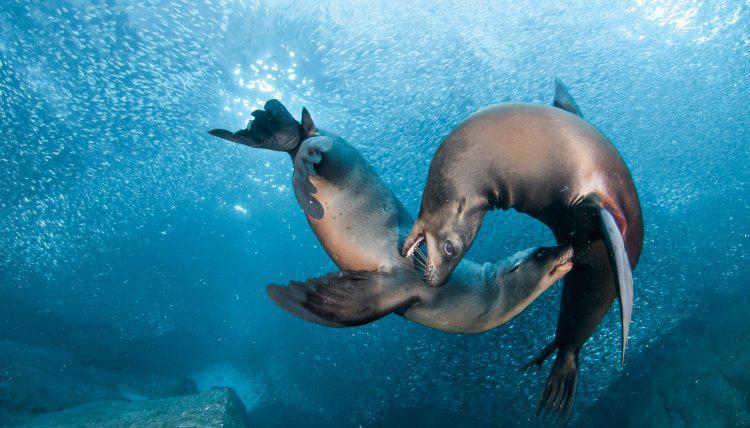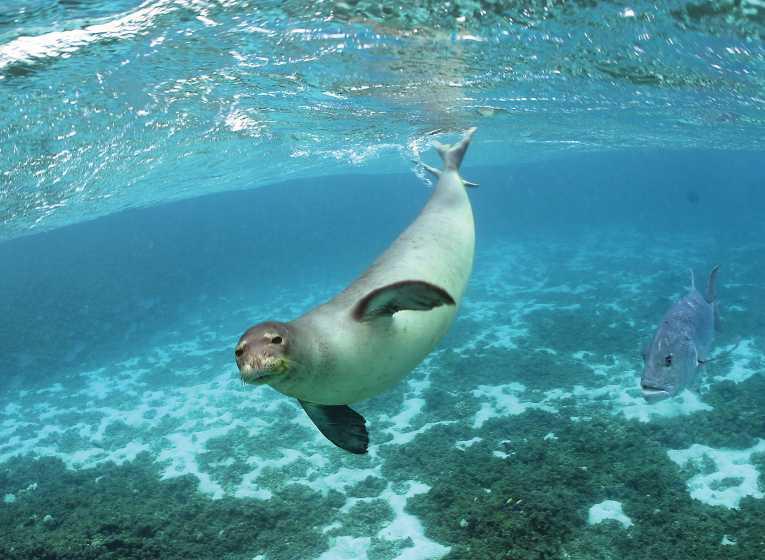The first image is the image on the left, the second image is the image on the right. Examine the images to the left and right. Is the description "The left image contains no more than one seal." accurate? Answer yes or no. No. The first image is the image on the left, the second image is the image on the right. For the images displayed, is the sentence "An image shows a seal with its nose close to the camera, and no image contains more than one seal in the foreground." factually correct? Answer yes or no. No. 